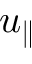Convert formula to latex. <formula><loc_0><loc_0><loc_500><loc_500>u _ { \| }</formula> 